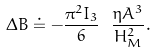<formula> <loc_0><loc_0><loc_500><loc_500>\Delta B \doteq - \frac { \pi ^ { 2 } I _ { 3 } } 6 \ \frac { \eta A ^ { 3 } } { H _ { M } ^ { 2 } } .</formula> 